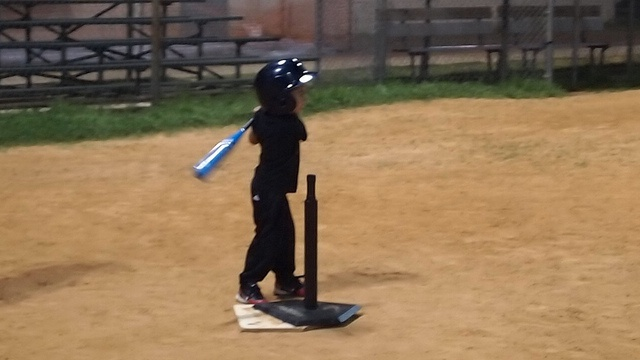Describe the objects in this image and their specific colors. I can see people in black, tan, and gray tones, bench in black and gray tones, bench in black and gray tones, bench in black and gray tones, and bench in black and gray tones in this image. 